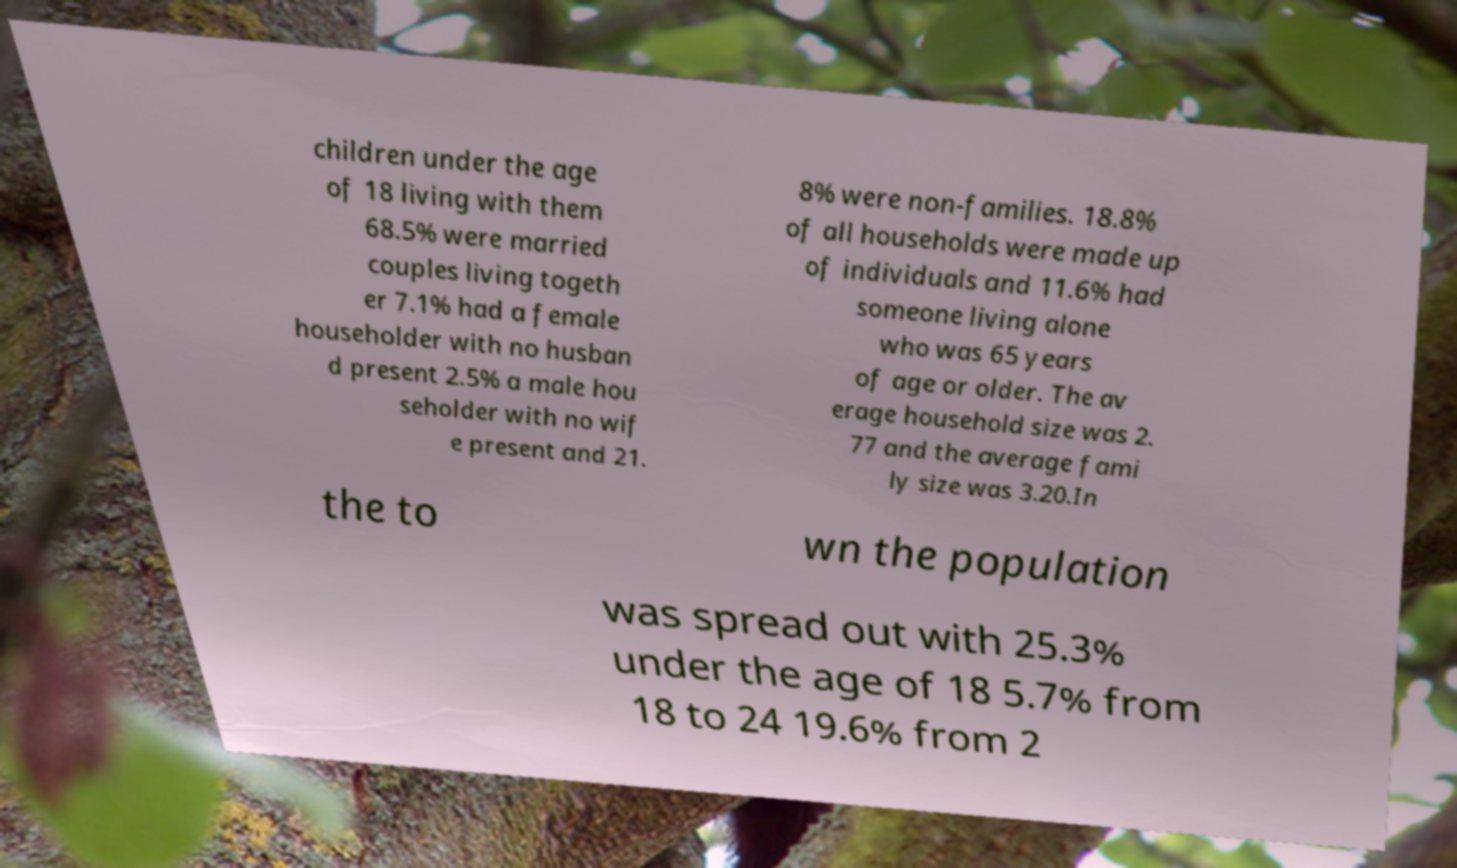Please identify and transcribe the text found in this image. children under the age of 18 living with them 68.5% were married couples living togeth er 7.1% had a female householder with no husban d present 2.5% a male hou seholder with no wif e present and 21. 8% were non-families. 18.8% of all households were made up of individuals and 11.6% had someone living alone who was 65 years of age or older. The av erage household size was 2. 77 and the average fami ly size was 3.20.In the to wn the population was spread out with 25.3% under the age of 18 5.7% from 18 to 24 19.6% from 2 